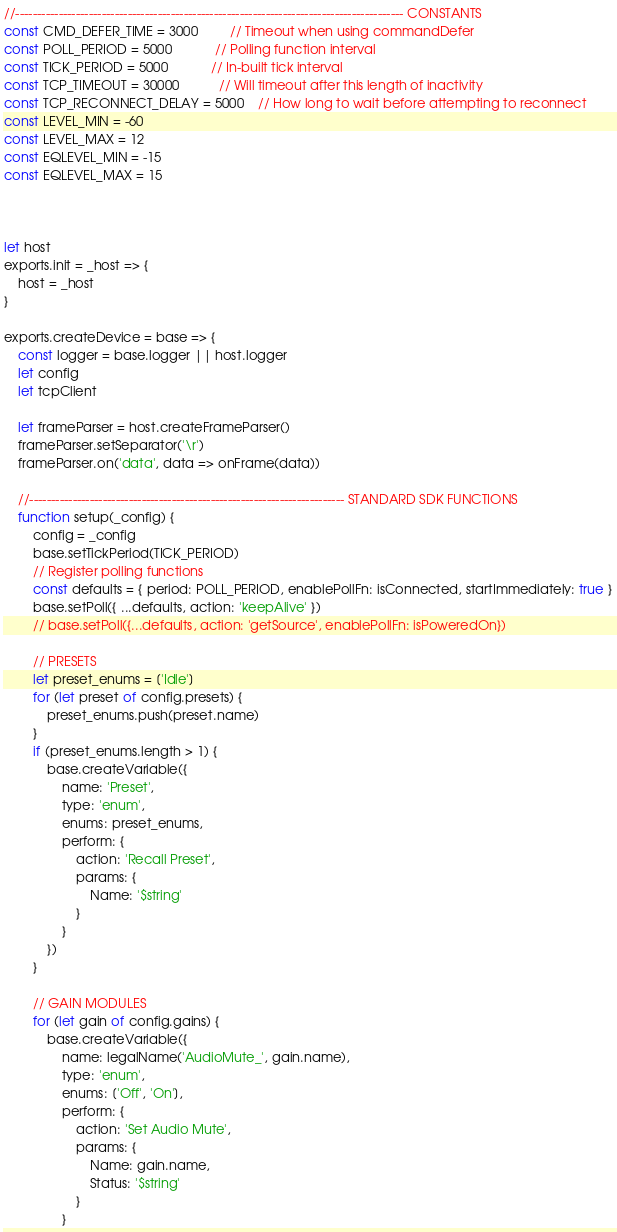Convert code to text. <code><loc_0><loc_0><loc_500><loc_500><_JavaScript_>//------------------------------------------------------------------------------------------ CONSTANTS
const CMD_DEFER_TIME = 3000         // Timeout when using commandDefer
const POLL_PERIOD = 5000            // Polling function interval
const TICK_PERIOD = 5000            // In-built tick interval
const TCP_TIMEOUT = 30000           // Will timeout after this length of inactivity
const TCP_RECONNECT_DELAY = 5000    // How long to wait before attempting to reconnect
const LEVEL_MIN = -60
const LEVEL_MAX = 12
const EQLEVEL_MIN = -15
const EQLEVEL_MAX = 15



let host
exports.init = _host => {
    host = _host
}

exports.createDevice = base => {
    const logger = base.logger || host.logger
    let config
    let tcpClient

    let frameParser = host.createFrameParser()
    frameParser.setSeparator('\r')
    frameParser.on('data', data => onFrame(data))

    //------------------------------------------------------------------------- STANDARD SDK FUNCTIONS
    function setup(_config) {
        config = _config
        base.setTickPeriod(TICK_PERIOD)
        // Register polling functions
        const defaults = { period: POLL_PERIOD, enablePollFn: isConnected, startImmediately: true }
        base.setPoll({ ...defaults, action: 'keepAlive' })
        // base.setPoll({...defaults, action: 'getSource', enablePollFn: isPoweredOn})

        // PRESETS
        let preset_enums = ['Idle']
        for (let preset of config.presets) {
            preset_enums.push(preset.name)
        }
        if (preset_enums.length > 1) {
            base.createVariable({
                name: 'Preset',
                type: 'enum',
                enums: preset_enums,
                perform: {
                    action: 'Recall Preset',
                    params: {
                        Name: '$string'
                    }
                }
            })
        }

        // GAIN MODULES
        for (let gain of config.gains) {
            base.createVariable({
                name: legalName('AudioMute_', gain.name),
                type: 'enum',
                enums: ['Off', 'On'],
                perform: {
                    action: 'Set Audio Mute',
                    params: {
                        Name: gain.name,
                        Status: '$string'
                    }
                }</code> 